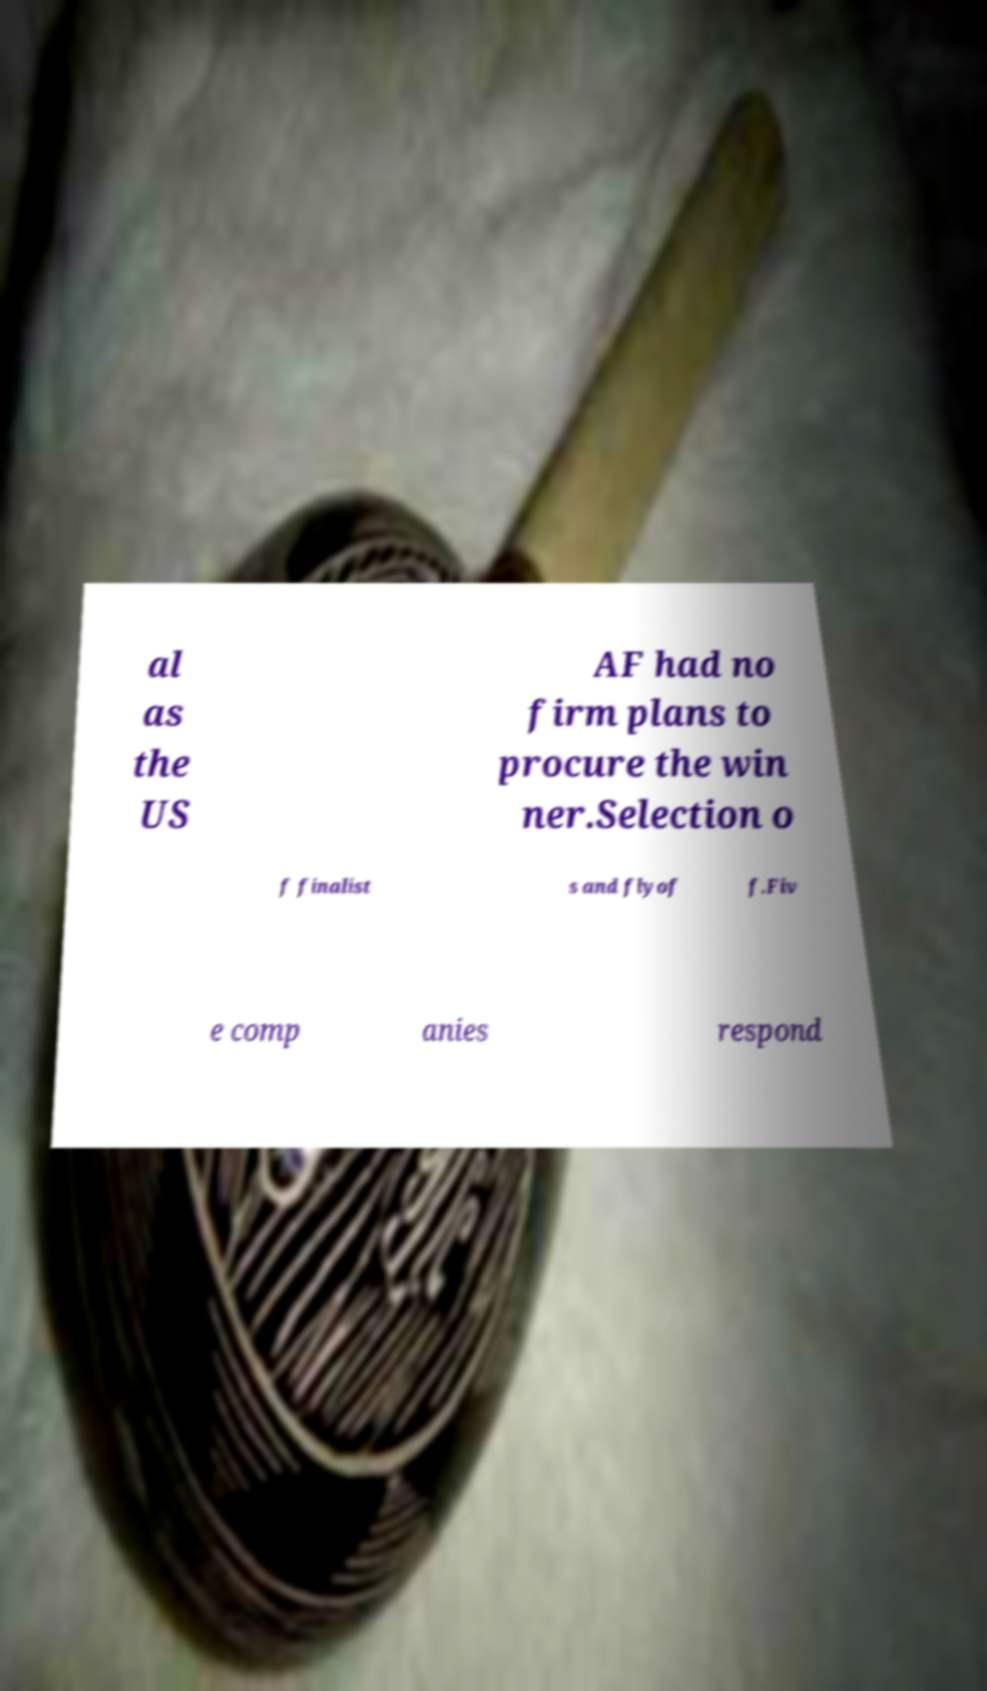Could you extract and type out the text from this image? al as the US AF had no firm plans to procure the win ner.Selection o f finalist s and flyof f.Fiv e comp anies respond 